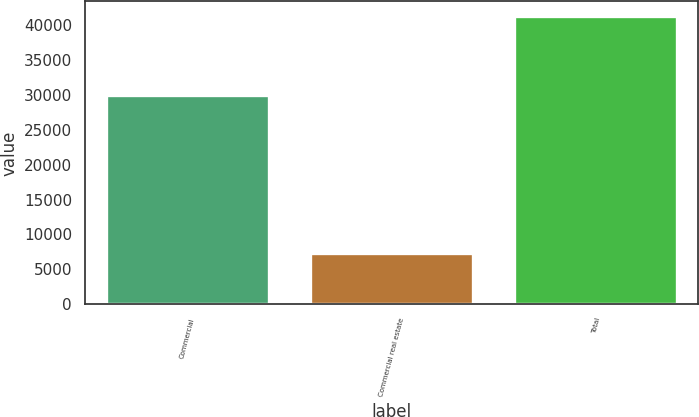Convert chart. <chart><loc_0><loc_0><loc_500><loc_500><bar_chart><fcel>Commercial<fcel>Commercial real estate<fcel>Total<nl><fcel>30022<fcel>7354<fcel>41300<nl></chart> 